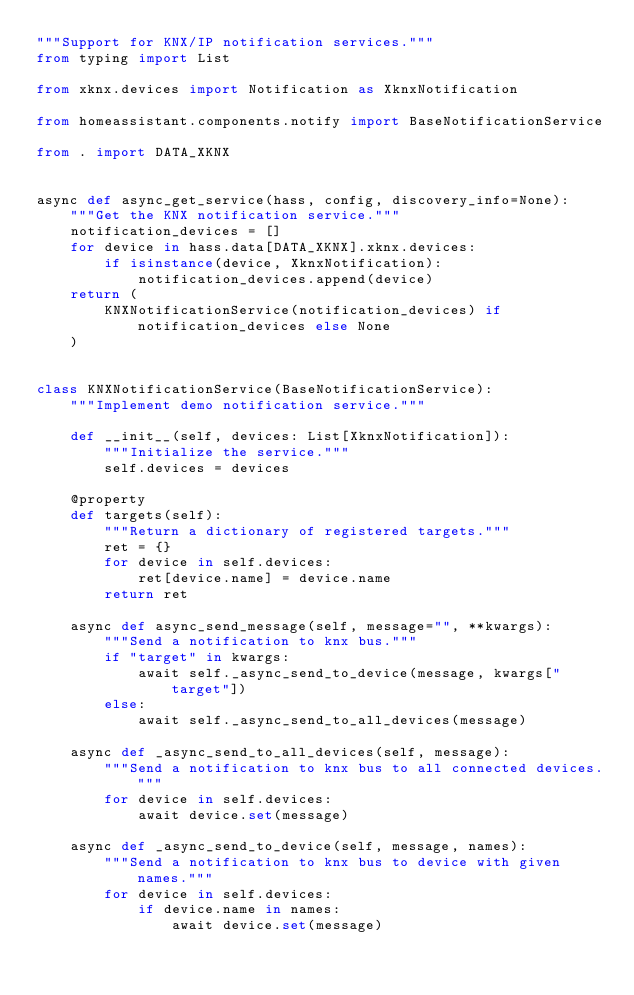<code> <loc_0><loc_0><loc_500><loc_500><_Python_>"""Support for KNX/IP notification services."""
from typing import List

from xknx.devices import Notification as XknxNotification

from homeassistant.components.notify import BaseNotificationService

from . import DATA_XKNX


async def async_get_service(hass, config, discovery_info=None):
    """Get the KNX notification service."""
    notification_devices = []
    for device in hass.data[DATA_XKNX].xknx.devices:
        if isinstance(device, XknxNotification):
            notification_devices.append(device)
    return (
        KNXNotificationService(notification_devices) if notification_devices else None
    )


class KNXNotificationService(BaseNotificationService):
    """Implement demo notification service."""

    def __init__(self, devices: List[XknxNotification]):
        """Initialize the service."""
        self.devices = devices

    @property
    def targets(self):
        """Return a dictionary of registered targets."""
        ret = {}
        for device in self.devices:
            ret[device.name] = device.name
        return ret

    async def async_send_message(self, message="", **kwargs):
        """Send a notification to knx bus."""
        if "target" in kwargs:
            await self._async_send_to_device(message, kwargs["target"])
        else:
            await self._async_send_to_all_devices(message)

    async def _async_send_to_all_devices(self, message):
        """Send a notification to knx bus to all connected devices."""
        for device in self.devices:
            await device.set(message)

    async def _async_send_to_device(self, message, names):
        """Send a notification to knx bus to device with given names."""
        for device in self.devices:
            if device.name in names:
                await device.set(message)
</code> 